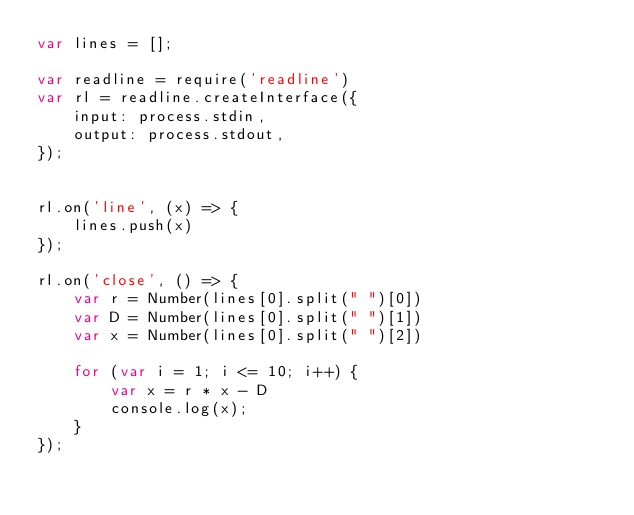Convert code to text. <code><loc_0><loc_0><loc_500><loc_500><_JavaScript_>var lines = [];

var readline = require('readline')
var rl = readline.createInterface({
    input: process.stdin,
    output: process.stdout,
});


rl.on('line', (x) => {
    lines.push(x)
});

rl.on('close', () => {
    var r = Number(lines[0].split(" ")[0])
    var D = Number(lines[0].split(" ")[1])
    var x = Number(lines[0].split(" ")[2])

    for (var i = 1; i <= 10; i++) {
        var x = r * x - D
        console.log(x);
    }
});</code> 